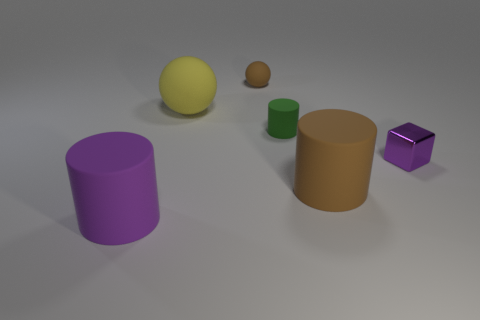Subtract all small green cylinders. How many cylinders are left? 2 Add 3 big yellow shiny cylinders. How many objects exist? 9 Subtract all cubes. How many objects are left? 5 Subtract all yellow balls. How many balls are left? 1 Add 5 matte cylinders. How many matte cylinders are left? 8 Add 6 tiny purple shiny cubes. How many tiny purple shiny cubes exist? 7 Subtract 1 purple blocks. How many objects are left? 5 Subtract 2 cylinders. How many cylinders are left? 1 Subtract all yellow cylinders. Subtract all yellow balls. How many cylinders are left? 3 Subtract all big green cubes. Subtract all spheres. How many objects are left? 4 